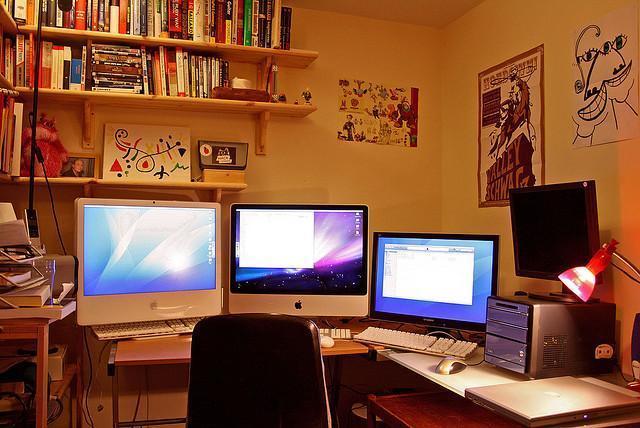How many screens do you see?
Give a very brief answer. 4. How many tvs are there?
Give a very brief answer. 4. How many books can you see?
Give a very brief answer. 2. How many chairs can be seen?
Give a very brief answer. 1. 